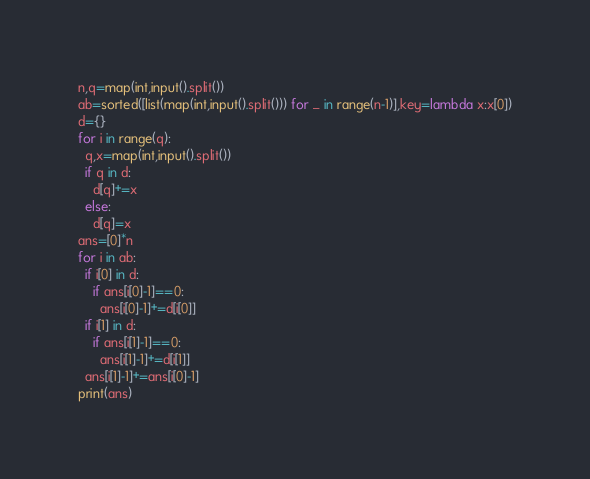<code> <loc_0><loc_0><loc_500><loc_500><_Python_>n,q=map(int,input().split())
ab=sorted([list(map(int,input().split())) for _ in range(n-1)],key=lambda x:x[0])
d={}
for i in range(q):
  q,x=map(int,input().split())
  if q in d:
    d[q]+=x
  else:
    d[q]=x
ans=[0]*n
for i in ab:
  if i[0] in d:
    if ans[i[0]-1]==0:
      ans[i[0]-1]+=d[i[0]]
  if i[1] in d:
    if ans[i[1]-1]==0:
      ans[i[1]-1]+=d[i[1]]
  ans[i[1]-1]+=ans[i[0]-1]
print(ans)</code> 